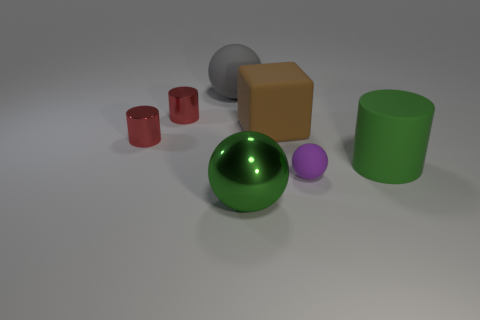Subtract all gray matte spheres. How many spheres are left? 2 Subtract all red blocks. How many red cylinders are left? 2 Subtract all green spheres. How many spheres are left? 2 Add 2 big matte spheres. How many objects exist? 9 Subtract 1 cylinders. How many cylinders are left? 2 Subtract all cubes. How many objects are left? 6 Add 6 large shiny things. How many large shiny things are left? 7 Add 1 tiny yellow rubber cubes. How many tiny yellow rubber cubes exist? 1 Subtract 1 green spheres. How many objects are left? 6 Subtract all blue balls. Subtract all blue blocks. How many balls are left? 3 